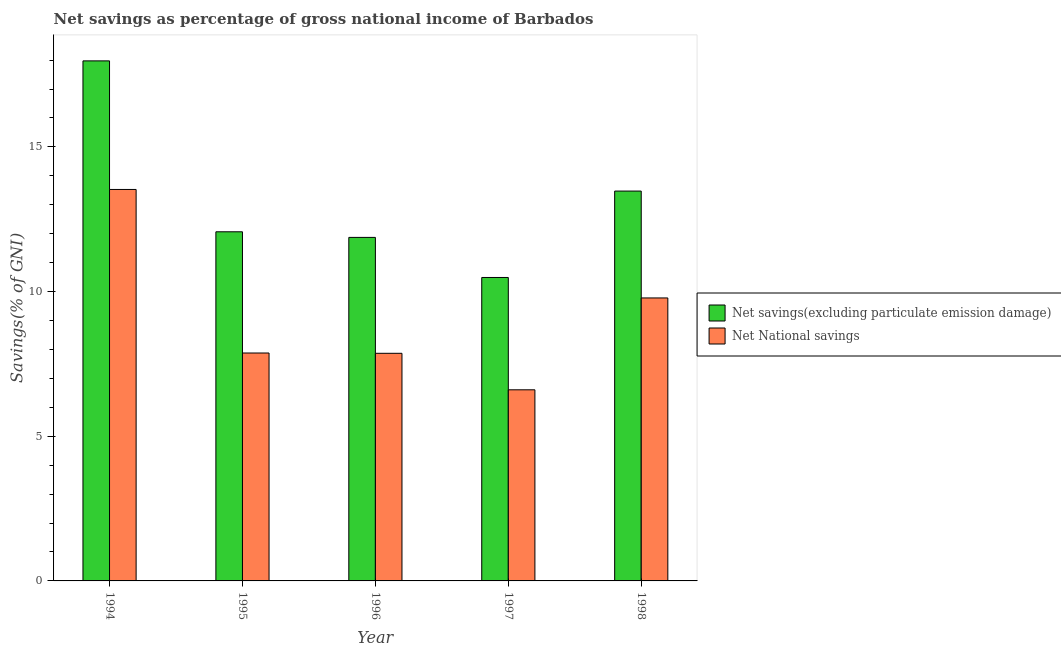How many different coloured bars are there?
Provide a succinct answer. 2. How many groups of bars are there?
Ensure brevity in your answer.  5. Are the number of bars on each tick of the X-axis equal?
Ensure brevity in your answer.  Yes. How many bars are there on the 2nd tick from the left?
Provide a short and direct response. 2. How many bars are there on the 2nd tick from the right?
Your answer should be compact. 2. In how many cases, is the number of bars for a given year not equal to the number of legend labels?
Make the answer very short. 0. What is the net national savings in 1998?
Offer a very short reply. 9.78. Across all years, what is the maximum net national savings?
Ensure brevity in your answer.  13.53. Across all years, what is the minimum net national savings?
Make the answer very short. 6.61. What is the total net national savings in the graph?
Offer a terse response. 45.66. What is the difference between the net national savings in 1996 and that in 1997?
Your answer should be very brief. 1.26. What is the difference between the net savings(excluding particulate emission damage) in 1994 and the net national savings in 1998?
Ensure brevity in your answer.  4.5. What is the average net savings(excluding particulate emission damage) per year?
Your answer should be compact. 13.17. In the year 1996, what is the difference between the net national savings and net savings(excluding particulate emission damage)?
Offer a very short reply. 0. What is the ratio of the net savings(excluding particulate emission damage) in 1995 to that in 1997?
Provide a succinct answer. 1.15. Is the net savings(excluding particulate emission damage) in 1995 less than that in 1998?
Keep it short and to the point. Yes. What is the difference between the highest and the second highest net savings(excluding particulate emission damage)?
Your answer should be compact. 4.5. What is the difference between the highest and the lowest net savings(excluding particulate emission damage)?
Your response must be concise. 7.49. In how many years, is the net national savings greater than the average net national savings taken over all years?
Keep it short and to the point. 2. Is the sum of the net national savings in 1996 and 1998 greater than the maximum net savings(excluding particulate emission damage) across all years?
Ensure brevity in your answer.  Yes. What does the 2nd bar from the left in 1997 represents?
Give a very brief answer. Net National savings. What does the 2nd bar from the right in 1994 represents?
Provide a short and direct response. Net savings(excluding particulate emission damage). How many bars are there?
Provide a succinct answer. 10. Are all the bars in the graph horizontal?
Your response must be concise. No. How many years are there in the graph?
Your answer should be very brief. 5. Are the values on the major ticks of Y-axis written in scientific E-notation?
Provide a succinct answer. No. Does the graph contain any zero values?
Offer a terse response. No. How many legend labels are there?
Give a very brief answer. 2. How are the legend labels stacked?
Ensure brevity in your answer.  Vertical. What is the title of the graph?
Keep it short and to the point. Net savings as percentage of gross national income of Barbados. What is the label or title of the X-axis?
Offer a terse response. Year. What is the label or title of the Y-axis?
Keep it short and to the point. Savings(% of GNI). What is the Savings(% of GNI) of Net savings(excluding particulate emission damage) in 1994?
Keep it short and to the point. 17.97. What is the Savings(% of GNI) of Net National savings in 1994?
Your response must be concise. 13.53. What is the Savings(% of GNI) of Net savings(excluding particulate emission damage) in 1995?
Keep it short and to the point. 12.07. What is the Savings(% of GNI) of Net National savings in 1995?
Offer a terse response. 7.88. What is the Savings(% of GNI) of Net savings(excluding particulate emission damage) in 1996?
Give a very brief answer. 11.87. What is the Savings(% of GNI) of Net National savings in 1996?
Keep it short and to the point. 7.87. What is the Savings(% of GNI) of Net savings(excluding particulate emission damage) in 1997?
Your answer should be compact. 10.49. What is the Savings(% of GNI) of Net National savings in 1997?
Offer a terse response. 6.61. What is the Savings(% of GNI) of Net savings(excluding particulate emission damage) in 1998?
Offer a very short reply. 13.47. What is the Savings(% of GNI) in Net National savings in 1998?
Your response must be concise. 9.78. Across all years, what is the maximum Savings(% of GNI) of Net savings(excluding particulate emission damage)?
Give a very brief answer. 17.97. Across all years, what is the maximum Savings(% of GNI) of Net National savings?
Keep it short and to the point. 13.53. Across all years, what is the minimum Savings(% of GNI) of Net savings(excluding particulate emission damage)?
Offer a terse response. 10.49. Across all years, what is the minimum Savings(% of GNI) in Net National savings?
Your answer should be compact. 6.61. What is the total Savings(% of GNI) in Net savings(excluding particulate emission damage) in the graph?
Keep it short and to the point. 65.87. What is the total Savings(% of GNI) of Net National savings in the graph?
Keep it short and to the point. 45.66. What is the difference between the Savings(% of GNI) of Net savings(excluding particulate emission damage) in 1994 and that in 1995?
Provide a short and direct response. 5.91. What is the difference between the Savings(% of GNI) of Net National savings in 1994 and that in 1995?
Your response must be concise. 5.65. What is the difference between the Savings(% of GNI) in Net savings(excluding particulate emission damage) in 1994 and that in 1996?
Your answer should be compact. 6.1. What is the difference between the Savings(% of GNI) in Net National savings in 1994 and that in 1996?
Make the answer very short. 5.66. What is the difference between the Savings(% of GNI) in Net savings(excluding particulate emission damage) in 1994 and that in 1997?
Offer a terse response. 7.49. What is the difference between the Savings(% of GNI) of Net National savings in 1994 and that in 1997?
Your answer should be compact. 6.92. What is the difference between the Savings(% of GNI) of Net savings(excluding particulate emission damage) in 1994 and that in 1998?
Provide a short and direct response. 4.5. What is the difference between the Savings(% of GNI) of Net National savings in 1994 and that in 1998?
Your response must be concise. 3.75. What is the difference between the Savings(% of GNI) in Net savings(excluding particulate emission damage) in 1995 and that in 1996?
Your response must be concise. 0.19. What is the difference between the Savings(% of GNI) in Net National savings in 1995 and that in 1996?
Your response must be concise. 0.01. What is the difference between the Savings(% of GNI) of Net savings(excluding particulate emission damage) in 1995 and that in 1997?
Give a very brief answer. 1.58. What is the difference between the Savings(% of GNI) of Net National savings in 1995 and that in 1997?
Provide a short and direct response. 1.27. What is the difference between the Savings(% of GNI) of Net savings(excluding particulate emission damage) in 1995 and that in 1998?
Give a very brief answer. -1.41. What is the difference between the Savings(% of GNI) of Net National savings in 1995 and that in 1998?
Provide a short and direct response. -1.9. What is the difference between the Savings(% of GNI) of Net savings(excluding particulate emission damage) in 1996 and that in 1997?
Make the answer very short. 1.39. What is the difference between the Savings(% of GNI) in Net National savings in 1996 and that in 1997?
Provide a succinct answer. 1.26. What is the difference between the Savings(% of GNI) of Net savings(excluding particulate emission damage) in 1996 and that in 1998?
Keep it short and to the point. -1.6. What is the difference between the Savings(% of GNI) of Net National savings in 1996 and that in 1998?
Provide a succinct answer. -1.91. What is the difference between the Savings(% of GNI) of Net savings(excluding particulate emission damage) in 1997 and that in 1998?
Your answer should be compact. -2.99. What is the difference between the Savings(% of GNI) of Net National savings in 1997 and that in 1998?
Ensure brevity in your answer.  -3.17. What is the difference between the Savings(% of GNI) of Net savings(excluding particulate emission damage) in 1994 and the Savings(% of GNI) of Net National savings in 1995?
Ensure brevity in your answer.  10.1. What is the difference between the Savings(% of GNI) in Net savings(excluding particulate emission damage) in 1994 and the Savings(% of GNI) in Net National savings in 1996?
Provide a succinct answer. 10.11. What is the difference between the Savings(% of GNI) in Net savings(excluding particulate emission damage) in 1994 and the Savings(% of GNI) in Net National savings in 1997?
Your answer should be compact. 11.37. What is the difference between the Savings(% of GNI) of Net savings(excluding particulate emission damage) in 1994 and the Savings(% of GNI) of Net National savings in 1998?
Offer a very short reply. 8.19. What is the difference between the Savings(% of GNI) in Net savings(excluding particulate emission damage) in 1995 and the Savings(% of GNI) in Net National savings in 1996?
Ensure brevity in your answer.  4.2. What is the difference between the Savings(% of GNI) in Net savings(excluding particulate emission damage) in 1995 and the Savings(% of GNI) in Net National savings in 1997?
Make the answer very short. 5.46. What is the difference between the Savings(% of GNI) of Net savings(excluding particulate emission damage) in 1995 and the Savings(% of GNI) of Net National savings in 1998?
Keep it short and to the point. 2.29. What is the difference between the Savings(% of GNI) in Net savings(excluding particulate emission damage) in 1996 and the Savings(% of GNI) in Net National savings in 1997?
Ensure brevity in your answer.  5.27. What is the difference between the Savings(% of GNI) of Net savings(excluding particulate emission damage) in 1996 and the Savings(% of GNI) of Net National savings in 1998?
Keep it short and to the point. 2.09. What is the difference between the Savings(% of GNI) in Net savings(excluding particulate emission damage) in 1997 and the Savings(% of GNI) in Net National savings in 1998?
Make the answer very short. 0.71. What is the average Savings(% of GNI) in Net savings(excluding particulate emission damage) per year?
Give a very brief answer. 13.17. What is the average Savings(% of GNI) of Net National savings per year?
Your answer should be compact. 9.13. In the year 1994, what is the difference between the Savings(% of GNI) in Net savings(excluding particulate emission damage) and Savings(% of GNI) in Net National savings?
Keep it short and to the point. 4.44. In the year 1995, what is the difference between the Savings(% of GNI) in Net savings(excluding particulate emission damage) and Savings(% of GNI) in Net National savings?
Ensure brevity in your answer.  4.19. In the year 1996, what is the difference between the Savings(% of GNI) in Net savings(excluding particulate emission damage) and Savings(% of GNI) in Net National savings?
Your answer should be compact. 4.01. In the year 1997, what is the difference between the Savings(% of GNI) in Net savings(excluding particulate emission damage) and Savings(% of GNI) in Net National savings?
Your response must be concise. 3.88. In the year 1998, what is the difference between the Savings(% of GNI) of Net savings(excluding particulate emission damage) and Savings(% of GNI) of Net National savings?
Ensure brevity in your answer.  3.69. What is the ratio of the Savings(% of GNI) in Net savings(excluding particulate emission damage) in 1994 to that in 1995?
Offer a very short reply. 1.49. What is the ratio of the Savings(% of GNI) in Net National savings in 1994 to that in 1995?
Offer a very short reply. 1.72. What is the ratio of the Savings(% of GNI) in Net savings(excluding particulate emission damage) in 1994 to that in 1996?
Make the answer very short. 1.51. What is the ratio of the Savings(% of GNI) of Net National savings in 1994 to that in 1996?
Give a very brief answer. 1.72. What is the ratio of the Savings(% of GNI) in Net savings(excluding particulate emission damage) in 1994 to that in 1997?
Provide a succinct answer. 1.71. What is the ratio of the Savings(% of GNI) of Net National savings in 1994 to that in 1997?
Offer a very short reply. 2.05. What is the ratio of the Savings(% of GNI) in Net savings(excluding particulate emission damage) in 1994 to that in 1998?
Provide a succinct answer. 1.33. What is the ratio of the Savings(% of GNI) in Net National savings in 1994 to that in 1998?
Provide a short and direct response. 1.38. What is the ratio of the Savings(% of GNI) in Net savings(excluding particulate emission damage) in 1995 to that in 1996?
Provide a short and direct response. 1.02. What is the ratio of the Savings(% of GNI) in Net savings(excluding particulate emission damage) in 1995 to that in 1997?
Provide a succinct answer. 1.15. What is the ratio of the Savings(% of GNI) in Net National savings in 1995 to that in 1997?
Provide a succinct answer. 1.19. What is the ratio of the Savings(% of GNI) of Net savings(excluding particulate emission damage) in 1995 to that in 1998?
Offer a very short reply. 0.9. What is the ratio of the Savings(% of GNI) of Net National savings in 1995 to that in 1998?
Your answer should be very brief. 0.81. What is the ratio of the Savings(% of GNI) in Net savings(excluding particulate emission damage) in 1996 to that in 1997?
Provide a succinct answer. 1.13. What is the ratio of the Savings(% of GNI) in Net National savings in 1996 to that in 1997?
Keep it short and to the point. 1.19. What is the ratio of the Savings(% of GNI) of Net savings(excluding particulate emission damage) in 1996 to that in 1998?
Offer a very short reply. 0.88. What is the ratio of the Savings(% of GNI) in Net National savings in 1996 to that in 1998?
Your answer should be compact. 0.8. What is the ratio of the Savings(% of GNI) of Net savings(excluding particulate emission damage) in 1997 to that in 1998?
Your answer should be compact. 0.78. What is the ratio of the Savings(% of GNI) of Net National savings in 1997 to that in 1998?
Your answer should be very brief. 0.68. What is the difference between the highest and the second highest Savings(% of GNI) in Net savings(excluding particulate emission damage)?
Your response must be concise. 4.5. What is the difference between the highest and the second highest Savings(% of GNI) of Net National savings?
Keep it short and to the point. 3.75. What is the difference between the highest and the lowest Savings(% of GNI) in Net savings(excluding particulate emission damage)?
Your response must be concise. 7.49. What is the difference between the highest and the lowest Savings(% of GNI) of Net National savings?
Give a very brief answer. 6.92. 